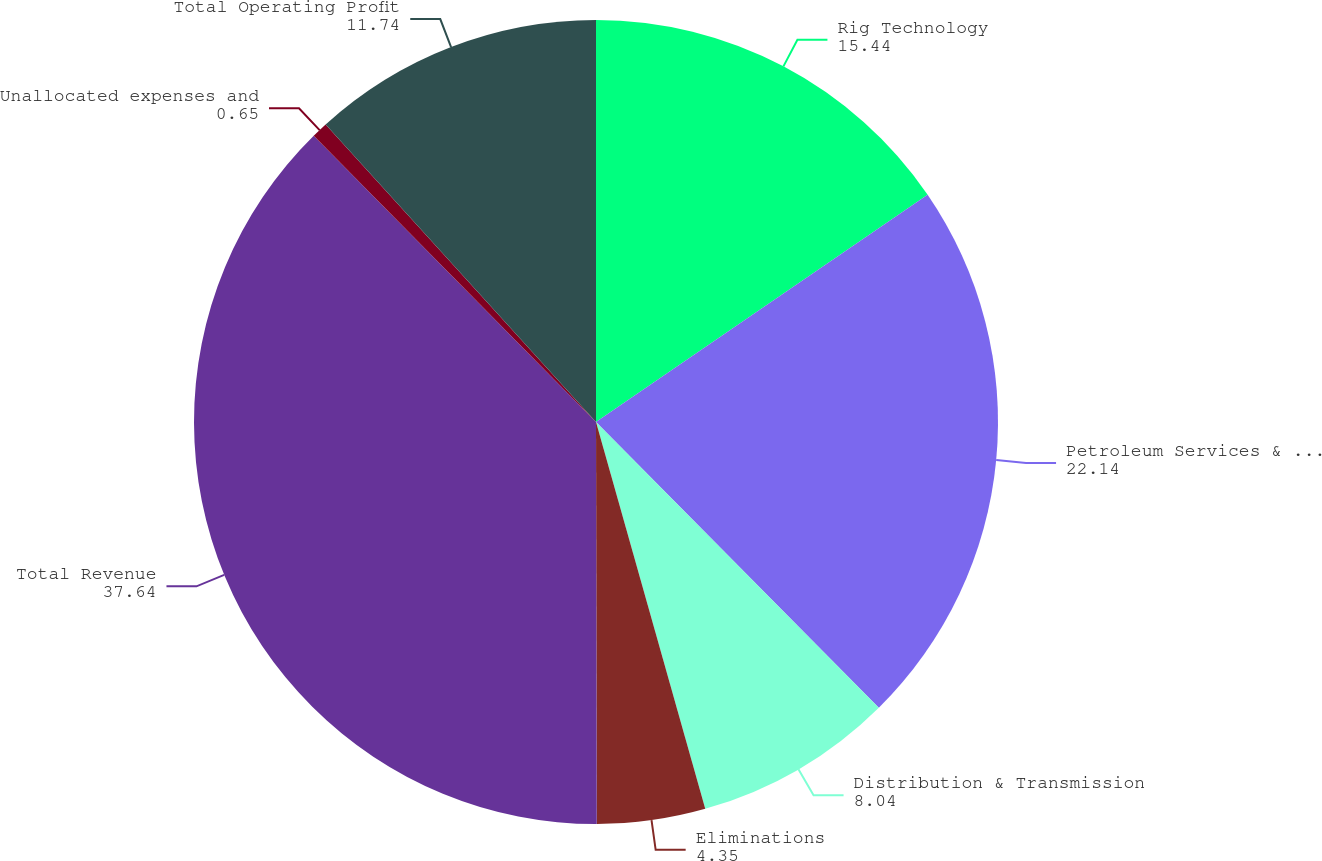<chart> <loc_0><loc_0><loc_500><loc_500><pie_chart><fcel>Rig Technology<fcel>Petroleum Services & Supplies<fcel>Distribution & Transmission<fcel>Eliminations<fcel>Total Revenue<fcel>Unallocated expenses and<fcel>Total Operating Profit<nl><fcel>15.44%<fcel>22.14%<fcel>8.04%<fcel>4.35%<fcel>37.64%<fcel>0.65%<fcel>11.74%<nl></chart> 